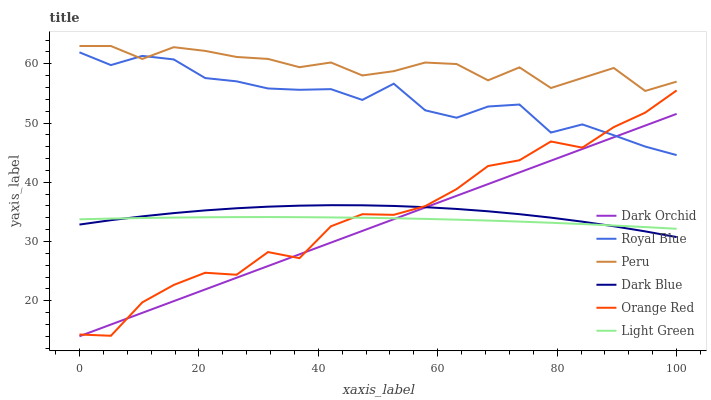Does Dark Orchid have the minimum area under the curve?
Answer yes or no. Yes. Does Peru have the maximum area under the curve?
Answer yes or no. Yes. Does Dark Blue have the minimum area under the curve?
Answer yes or no. No. Does Dark Blue have the maximum area under the curve?
Answer yes or no. No. Is Dark Orchid the smoothest?
Answer yes or no. Yes. Is Orange Red the roughest?
Answer yes or no. Yes. Is Dark Blue the smoothest?
Answer yes or no. No. Is Dark Blue the roughest?
Answer yes or no. No. Does Dark Blue have the lowest value?
Answer yes or no. No. Does Dark Blue have the highest value?
Answer yes or no. No. Is Light Green less than Peru?
Answer yes or no. Yes. Is Peru greater than Orange Red?
Answer yes or no. Yes. Does Light Green intersect Peru?
Answer yes or no. No. 